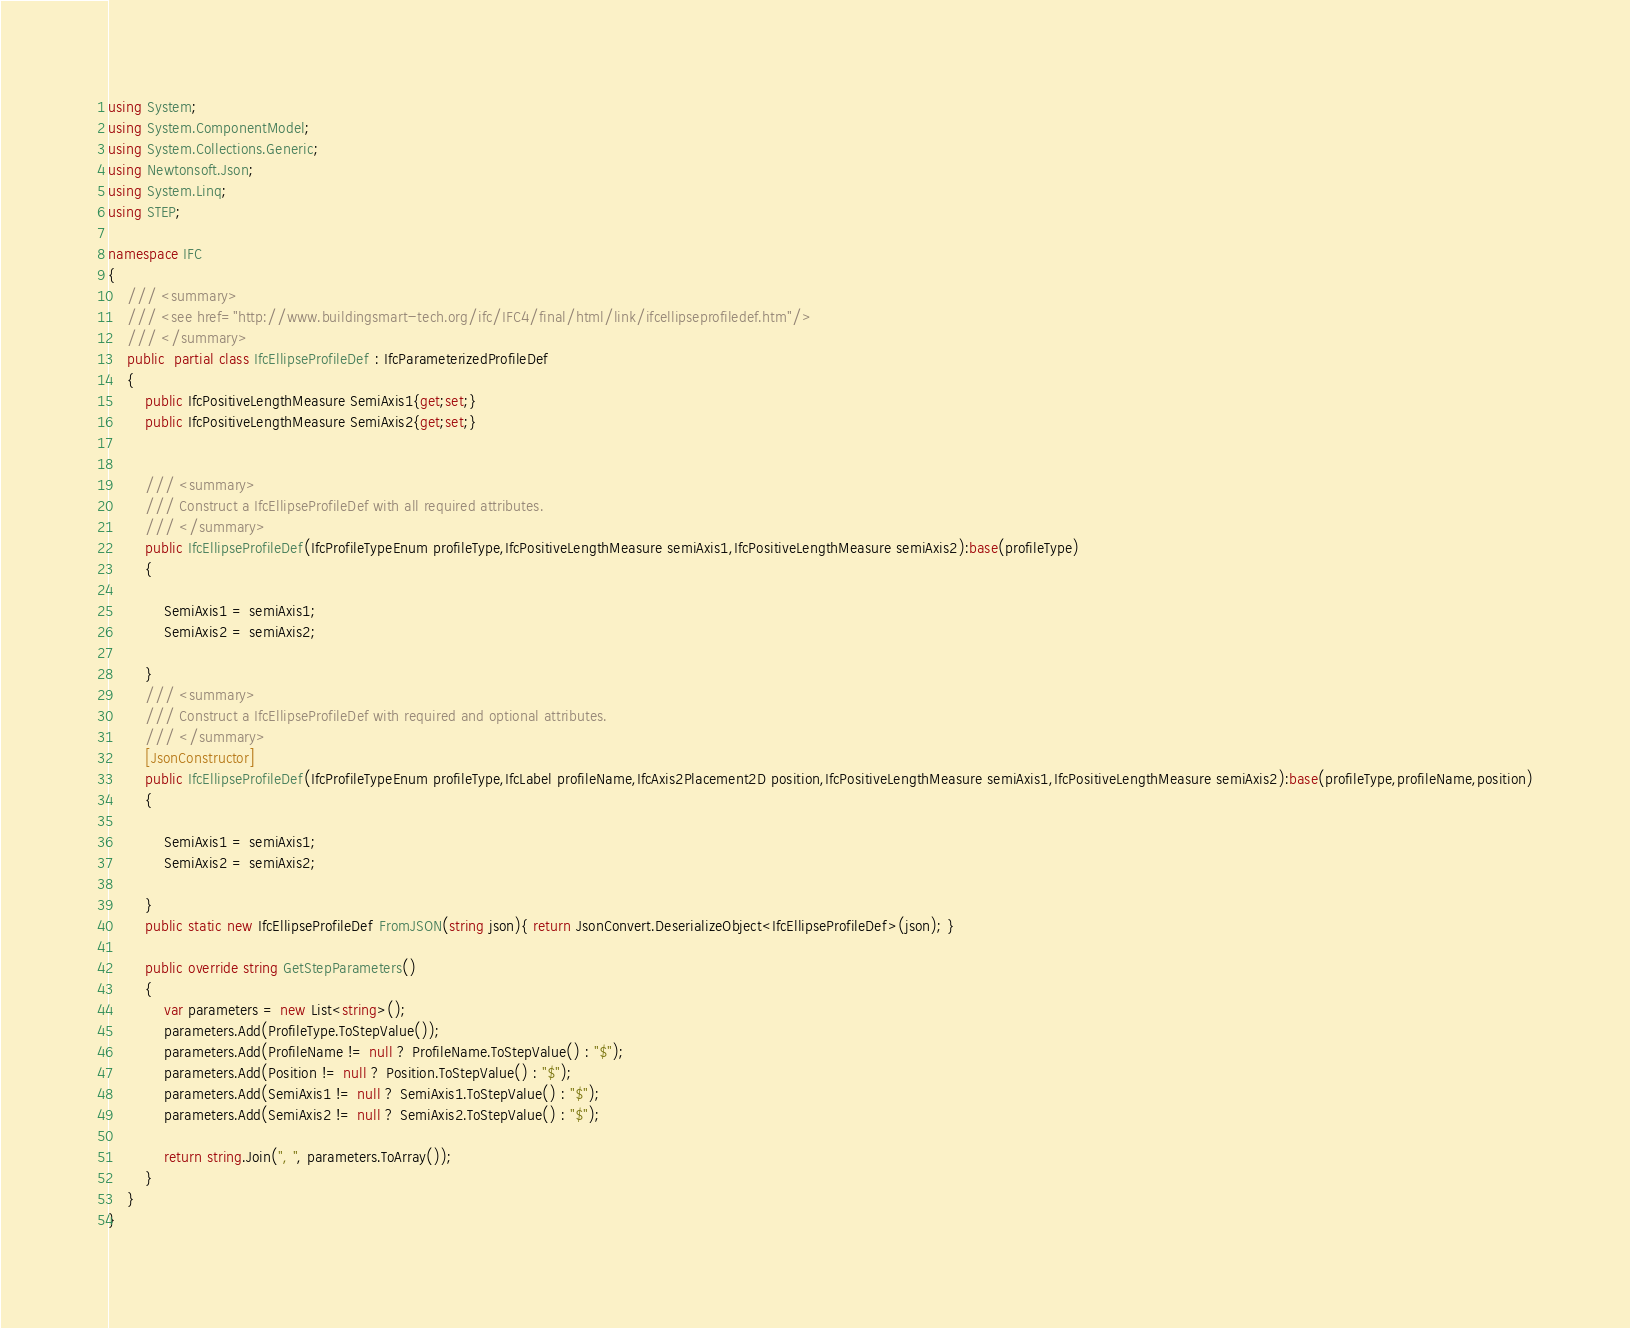Convert code to text. <code><loc_0><loc_0><loc_500><loc_500><_C#_>

using System;
using System.ComponentModel;
using System.Collections.Generic;
using Newtonsoft.Json;
using System.Linq;
using STEP;
	
namespace IFC
{
	/// <summary>
	/// <see href="http://www.buildingsmart-tech.org/ifc/IFC4/final/html/link/ifcellipseprofiledef.htm"/>
	/// </summary>
	public  partial class IfcEllipseProfileDef : IfcParameterizedProfileDef
	{
		public IfcPositiveLengthMeasure SemiAxis1{get;set;} 
		public IfcPositiveLengthMeasure SemiAxis2{get;set;} 


		/// <summary>
		/// Construct a IfcEllipseProfileDef with all required attributes.
		/// </summary>
		public IfcEllipseProfileDef(IfcProfileTypeEnum profileType,IfcPositiveLengthMeasure semiAxis1,IfcPositiveLengthMeasure semiAxis2):base(profileType)
		{

			SemiAxis1 = semiAxis1;
			SemiAxis2 = semiAxis2;

		}
		/// <summary>
		/// Construct a IfcEllipseProfileDef with required and optional attributes.
		/// </summary>
		[JsonConstructor]
		public IfcEllipseProfileDef(IfcProfileTypeEnum profileType,IfcLabel profileName,IfcAxis2Placement2D position,IfcPositiveLengthMeasure semiAxis1,IfcPositiveLengthMeasure semiAxis2):base(profileType,profileName,position)
		{

			SemiAxis1 = semiAxis1;
			SemiAxis2 = semiAxis2;

		}
		public static new IfcEllipseProfileDef FromJSON(string json){ return JsonConvert.DeserializeObject<IfcEllipseProfileDef>(json); }

        public override string GetStepParameters()
        {
            var parameters = new List<string>();
			parameters.Add(ProfileType.ToStepValue());
			parameters.Add(ProfileName != null ? ProfileName.ToStepValue() : "$");
			parameters.Add(Position != null ? Position.ToStepValue() : "$");
			parameters.Add(SemiAxis1 != null ? SemiAxis1.ToStepValue() : "$");
			parameters.Add(SemiAxis2 != null ? SemiAxis2.ToStepValue() : "$");

            return string.Join(", ", parameters.ToArray());
        }
	}
}
</code> 